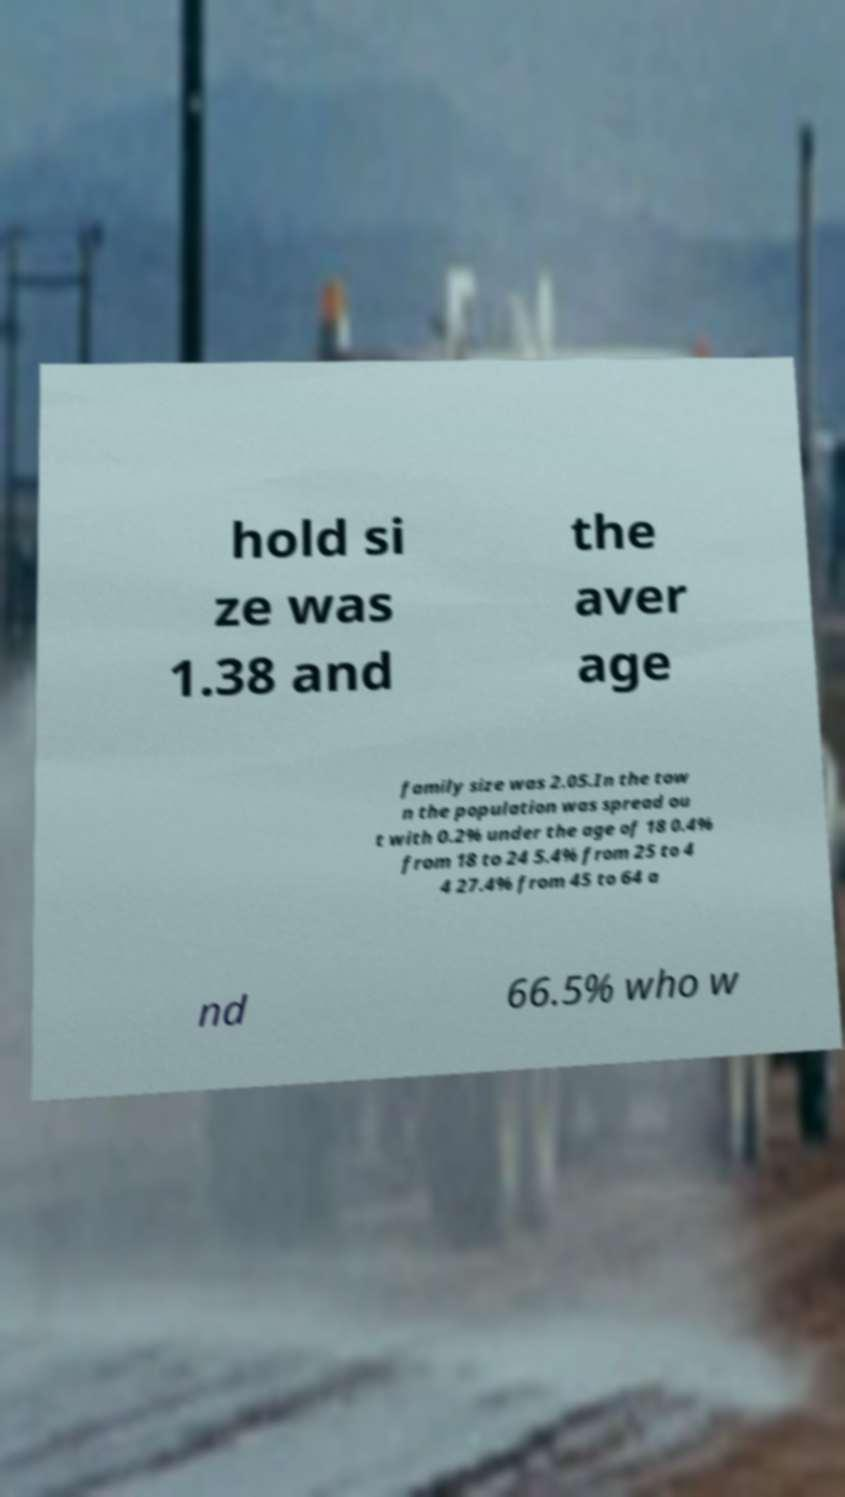Please identify and transcribe the text found in this image. hold si ze was 1.38 and the aver age family size was 2.05.In the tow n the population was spread ou t with 0.2% under the age of 18 0.4% from 18 to 24 5.4% from 25 to 4 4 27.4% from 45 to 64 a nd 66.5% who w 